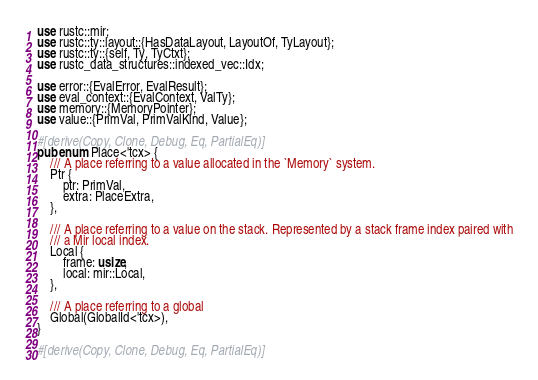Convert code to text. <code><loc_0><loc_0><loc_500><loc_500><_Rust_>use rustc::mir;
use rustc::ty::layout::{HasDataLayout, LayoutOf, TyLayout};
use rustc::ty::{self, Ty, TyCtxt};
use rustc_data_structures::indexed_vec::Idx;

use error::{EvalError, EvalResult};
use eval_context::{EvalContext, ValTy};
use memory::{MemoryPointer};
use value::{PrimVal, PrimValKind, Value};

#[derive(Copy, Clone, Debug, Eq, PartialEq)]
pub enum Place<'tcx> {
    /// A place referring to a value allocated in the `Memory` system.
    Ptr {
        ptr: PrimVal,
        extra: PlaceExtra,
    },

    /// A place referring to a value on the stack. Represented by a stack frame index paired with
    /// a Mir local index.
    Local {
        frame: usize,
        local: mir::Local,
    },

    /// A place referring to a global
    Global(GlobalId<'tcx>),
}

#[derive(Copy, Clone, Debug, Eq, PartialEq)]</code> 